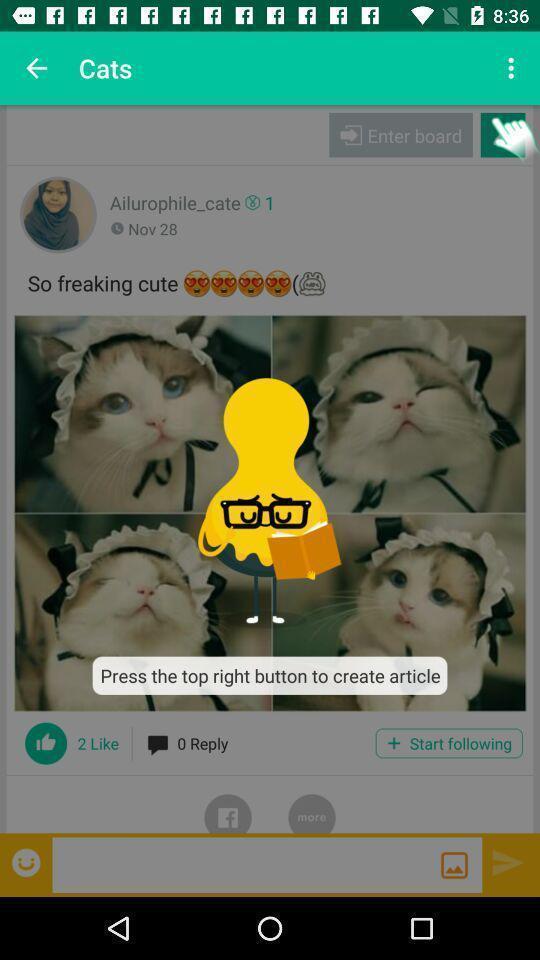What can you discern from this picture? Pop up notification instructions of the app. 